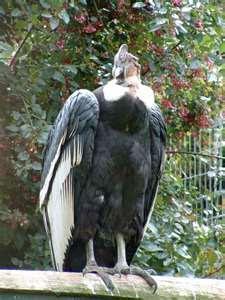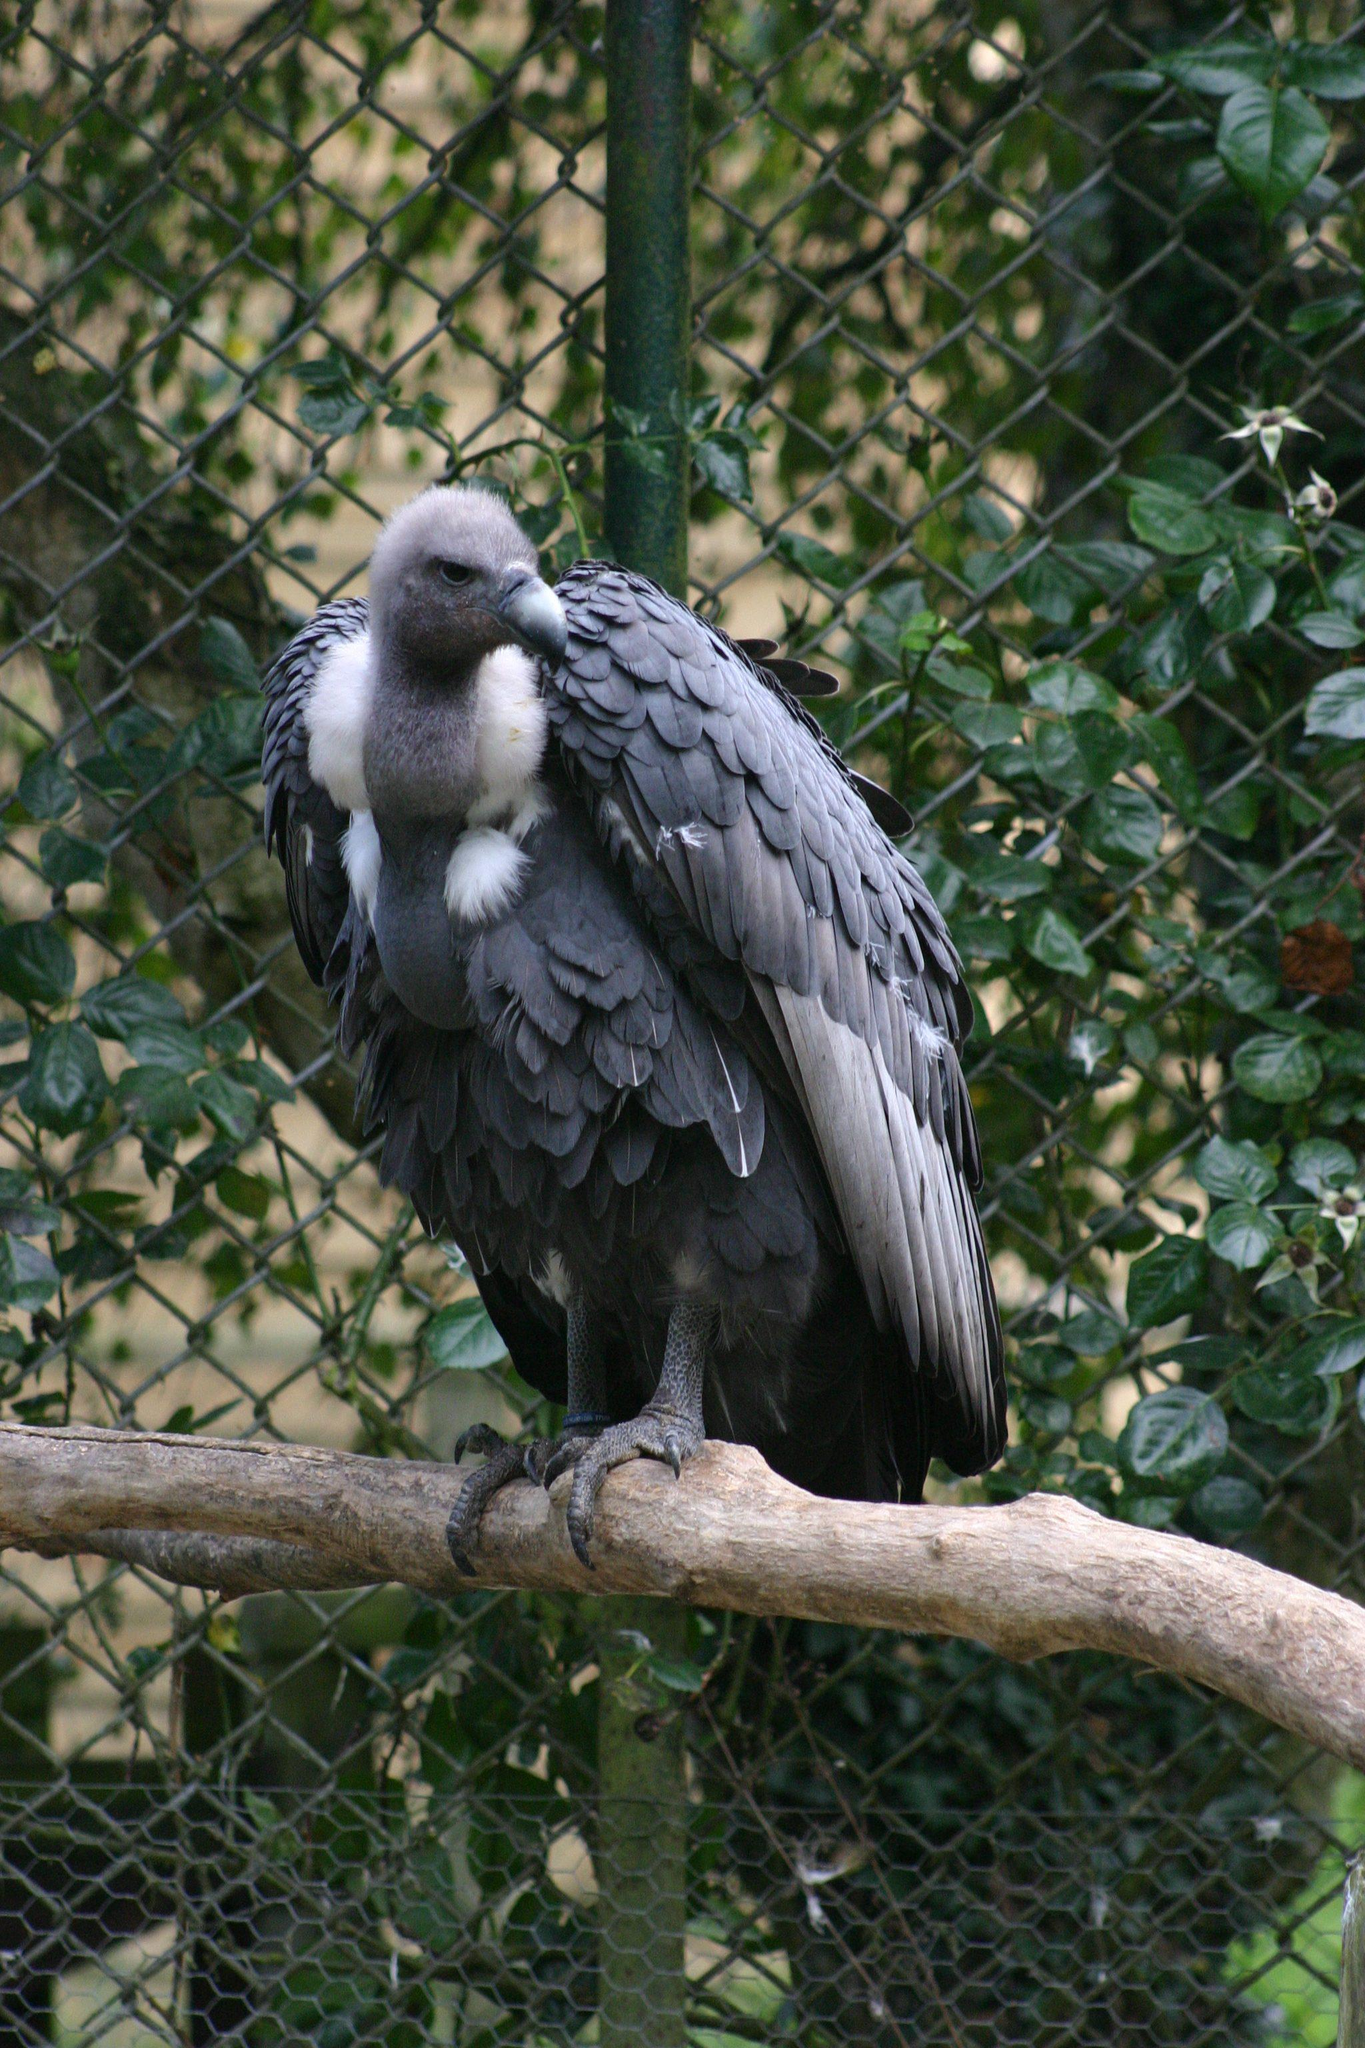The first image is the image on the left, the second image is the image on the right. Assess this claim about the two images: "An image shows two vultures in the foreground, at least one with its wings outspread.". Correct or not? Answer yes or no. No. The first image is the image on the left, the second image is the image on the right. Assess this claim about the two images: "In at least one image there is a total of five vultures.". Correct or not? Answer yes or no. No. 